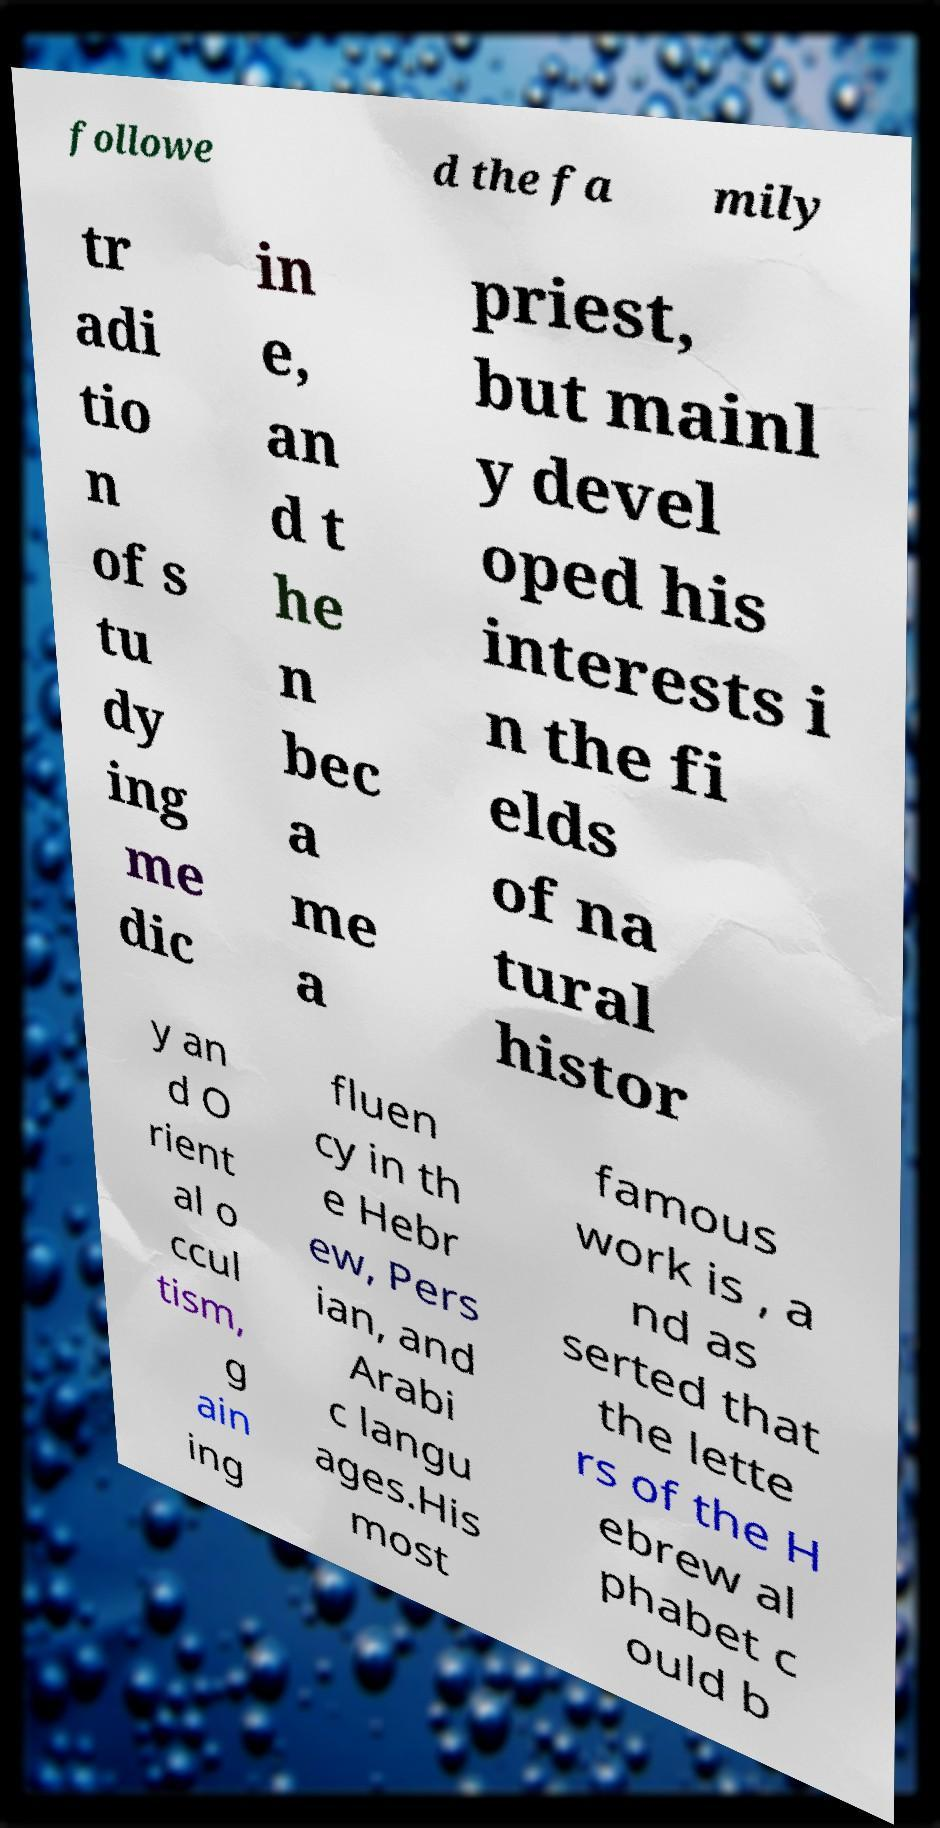Can you read and provide the text displayed in the image?This photo seems to have some interesting text. Can you extract and type it out for me? followe d the fa mily tr adi tio n of s tu dy ing me dic in e, an d t he n bec a me a priest, but mainl y devel oped his interests i n the fi elds of na tural histor y an d O rient al o ccul tism, g ain ing fluen cy in th e Hebr ew, Pers ian, and Arabi c langu ages.His most famous work is , a nd as serted that the lette rs of the H ebrew al phabet c ould b 